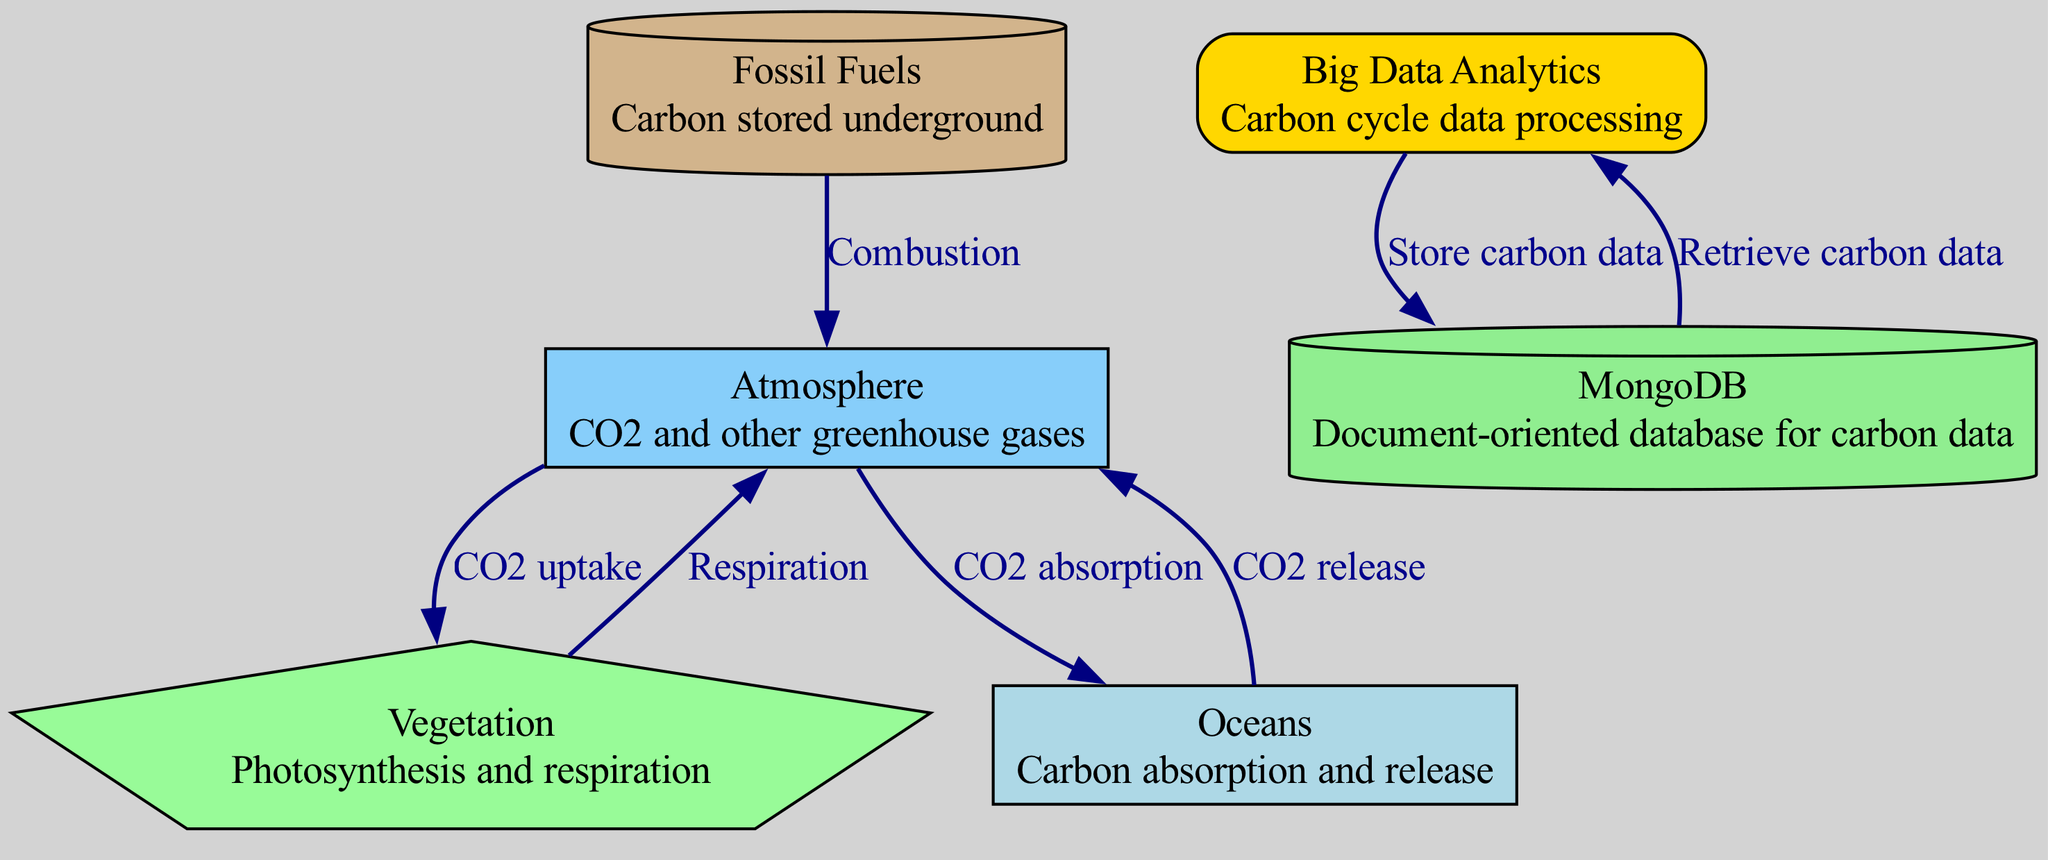What is the total number of nodes in the diagram? The diagram lists six different nodes: atmosphere, vegetation, oceans, fossil fuels, big data analytics, and MongoDB. Counting these gives us a total of six nodes.
Answer: six What flows from the atmosphere to vegetation? The diagram shows an edge labeled "CO2 uptake" that flows from the atmosphere to vegetation, indicating the movement of carbon dioxide during photosynthesis.
Answer: CO2 uptake How many edges are in the diagram? The diagram depicts six edges connecting the various nodes. These edges represent the interactions in the carbon cycle and the role of big data analytics.
Answer: six What process links fossil fuels to the atmosphere? The edge labeled "Combustion" connects fossil fuels to the atmosphere, indicating that the burning of fossil fuels releases carbon dioxide into the atmosphere.
Answer: Combustion Which node represents carbon absorption? In the diagram, the node "Oceans" describes its role in carbon absorption, indicating that oceans take in carbon dioxide from the atmosphere.
Answer: Oceans What is directed towards MongoDB from big data analytics? The diagram illustrates an edge labeled "Store carbon data" that flows from big data analytics to MongoDB, indicating the action of saving data related to the carbon cycle.
Answer: Store carbon data Which two nodes have a bidirectional flow? The nodes "Big Data Analytics" and "MongoDB" have a bidirectional edge where data flow is described as "Store carbon data" and "Retrieve carbon data". This indicates a continuous exchange of information.
Answer: Big Data Analytics and MongoDB What type of database is MongoDB identified as? According to the diagram, MongoDB is described as a "Document-oriented database for carbon data", highlighting its specialized function in handling carbon cycle data.
Answer: Document-oriented database Which process sends CO2 back to the atmosphere from vegetation? The diagram indicates that "Respiration" is the process that sends carbon dioxide back from vegetation to the atmosphere, representing the natural cycle of carbon release.
Answer: Respiration What does the edge from oceans to atmosphere represent? The edge labeled "CO2 release" represents the process by which carbon dioxide is released back into the atmosphere from the oceans, indicating the dynamic nature of the carbon cycle.
Answer: CO2 release 